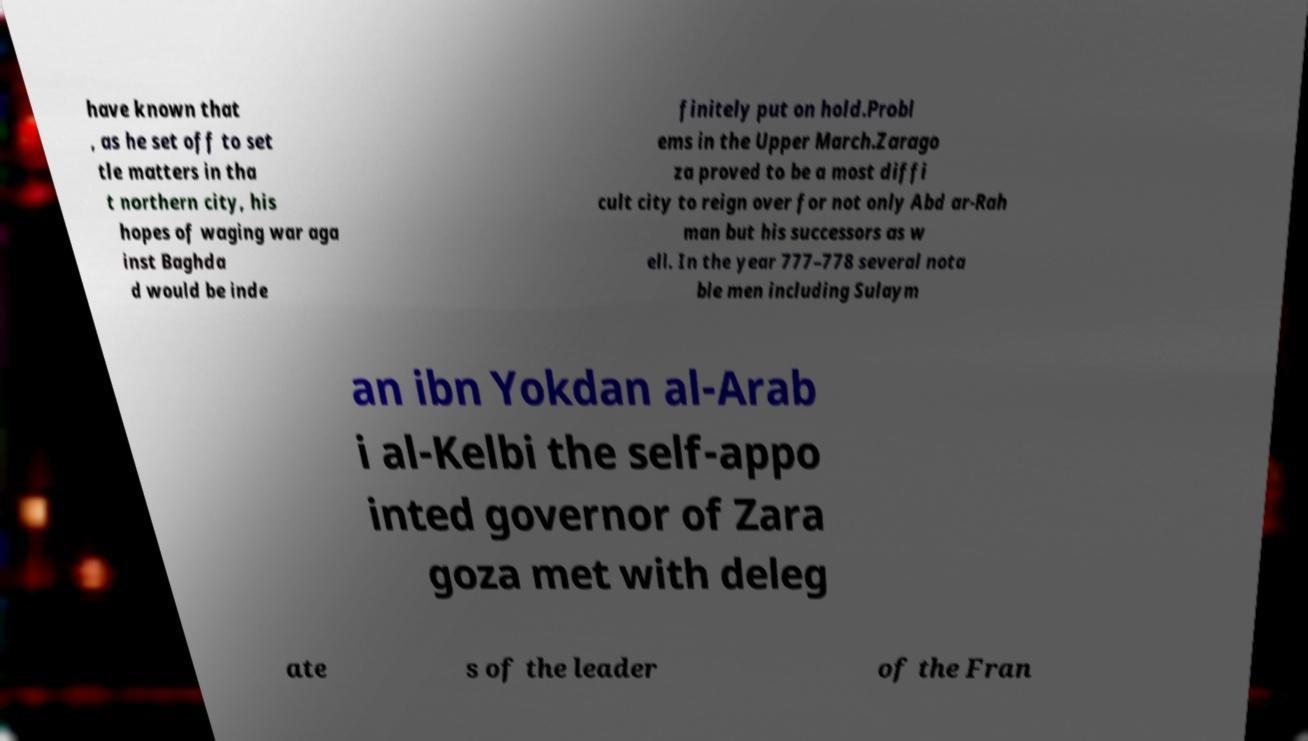For documentation purposes, I need the text within this image transcribed. Could you provide that? have known that , as he set off to set tle matters in tha t northern city, his hopes of waging war aga inst Baghda d would be inde finitely put on hold.Probl ems in the Upper March.Zarago za proved to be a most diffi cult city to reign over for not only Abd ar-Rah man but his successors as w ell. In the year 777–778 several nota ble men including Sulaym an ibn Yokdan al-Arab i al-Kelbi the self-appo inted governor of Zara goza met with deleg ate s of the leader of the Fran 